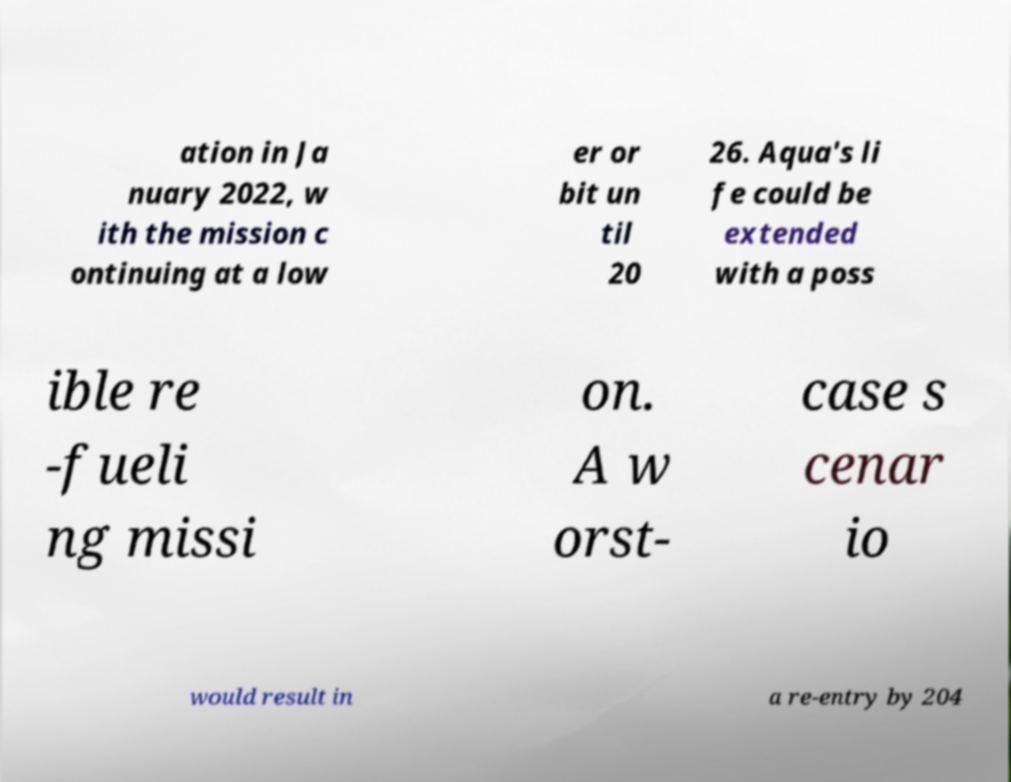What messages or text are displayed in this image? I need them in a readable, typed format. ation in Ja nuary 2022, w ith the mission c ontinuing at a low er or bit un til 20 26. Aqua's li fe could be extended with a poss ible re -fueli ng missi on. A w orst- case s cenar io would result in a re-entry by 204 